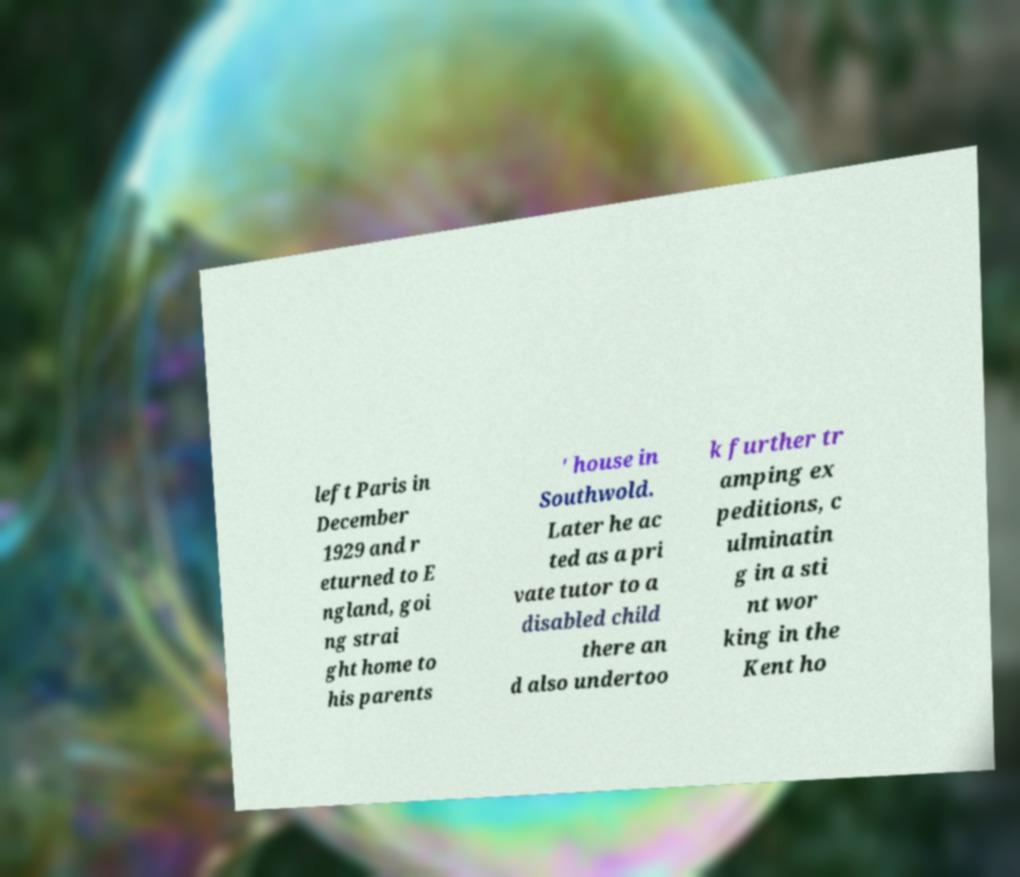Could you assist in decoding the text presented in this image and type it out clearly? left Paris in December 1929 and r eturned to E ngland, goi ng strai ght home to his parents ' house in Southwold. Later he ac ted as a pri vate tutor to a disabled child there an d also undertoo k further tr amping ex peditions, c ulminatin g in a sti nt wor king in the Kent ho 